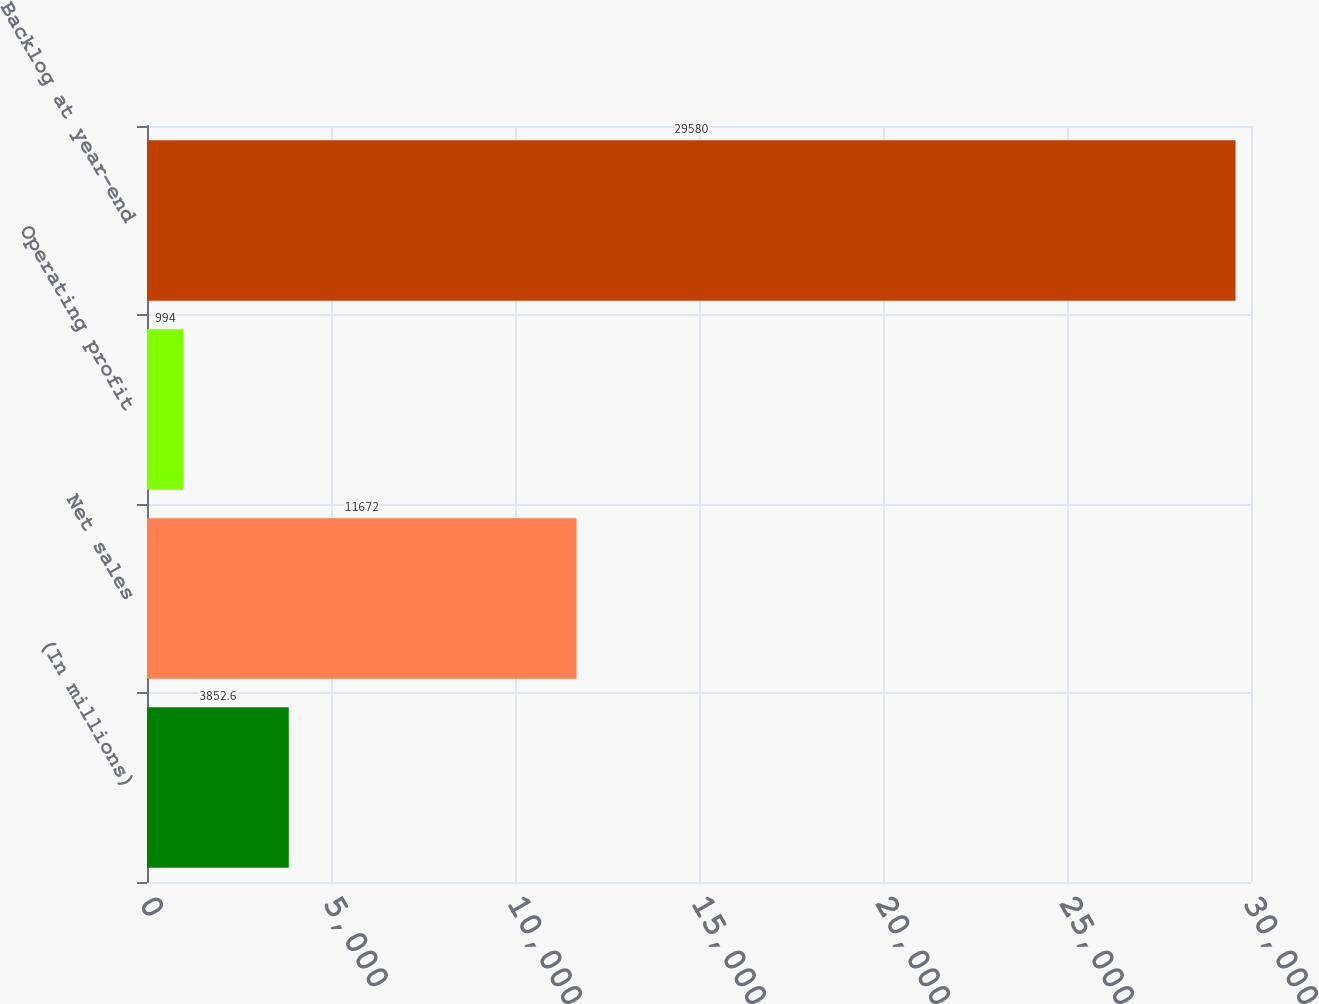Convert chart to OTSL. <chart><loc_0><loc_0><loc_500><loc_500><bar_chart><fcel>(In millions)<fcel>Net sales<fcel>Operating profit<fcel>Backlog at year-end<nl><fcel>3852.6<fcel>11672<fcel>994<fcel>29580<nl></chart> 